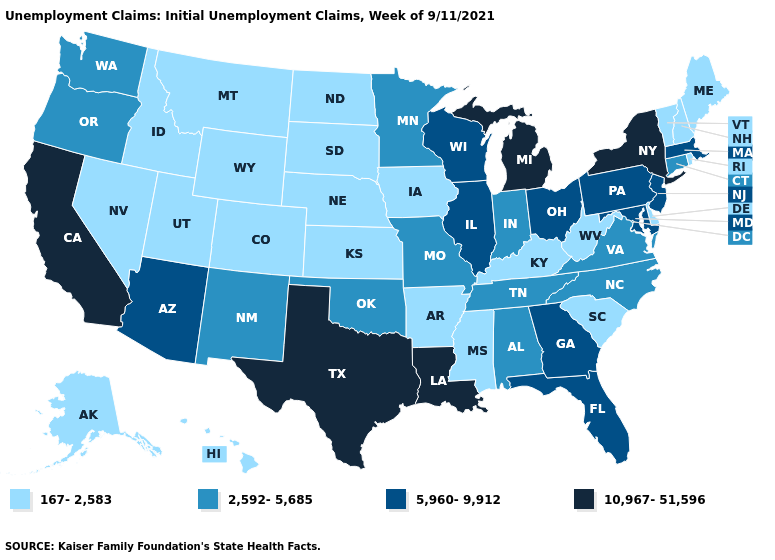Name the states that have a value in the range 167-2,583?
Quick response, please. Alaska, Arkansas, Colorado, Delaware, Hawaii, Idaho, Iowa, Kansas, Kentucky, Maine, Mississippi, Montana, Nebraska, Nevada, New Hampshire, North Dakota, Rhode Island, South Carolina, South Dakota, Utah, Vermont, West Virginia, Wyoming. Does Missouri have the same value as South Dakota?
Write a very short answer. No. Name the states that have a value in the range 167-2,583?
Quick response, please. Alaska, Arkansas, Colorado, Delaware, Hawaii, Idaho, Iowa, Kansas, Kentucky, Maine, Mississippi, Montana, Nebraska, Nevada, New Hampshire, North Dakota, Rhode Island, South Carolina, South Dakota, Utah, Vermont, West Virginia, Wyoming. Does Connecticut have the same value as Alabama?
Write a very short answer. Yes. What is the value of Montana?
Be succinct. 167-2,583. Does South Dakota have the highest value in the MidWest?
Give a very brief answer. No. What is the lowest value in the MidWest?
Short answer required. 167-2,583. What is the value of Washington?
Be succinct. 2,592-5,685. What is the lowest value in states that border Louisiana?
Answer briefly. 167-2,583. Does Michigan have the highest value in the MidWest?
Concise answer only. Yes. Name the states that have a value in the range 167-2,583?
Concise answer only. Alaska, Arkansas, Colorado, Delaware, Hawaii, Idaho, Iowa, Kansas, Kentucky, Maine, Mississippi, Montana, Nebraska, Nevada, New Hampshire, North Dakota, Rhode Island, South Carolina, South Dakota, Utah, Vermont, West Virginia, Wyoming. Among the states that border Missouri , does Nebraska have the lowest value?
Quick response, please. Yes. Among the states that border Maine , which have the highest value?
Keep it brief. New Hampshire. Which states have the lowest value in the USA?
Quick response, please. Alaska, Arkansas, Colorado, Delaware, Hawaii, Idaho, Iowa, Kansas, Kentucky, Maine, Mississippi, Montana, Nebraska, Nevada, New Hampshire, North Dakota, Rhode Island, South Carolina, South Dakota, Utah, Vermont, West Virginia, Wyoming. What is the value of New Mexico?
Answer briefly. 2,592-5,685. 